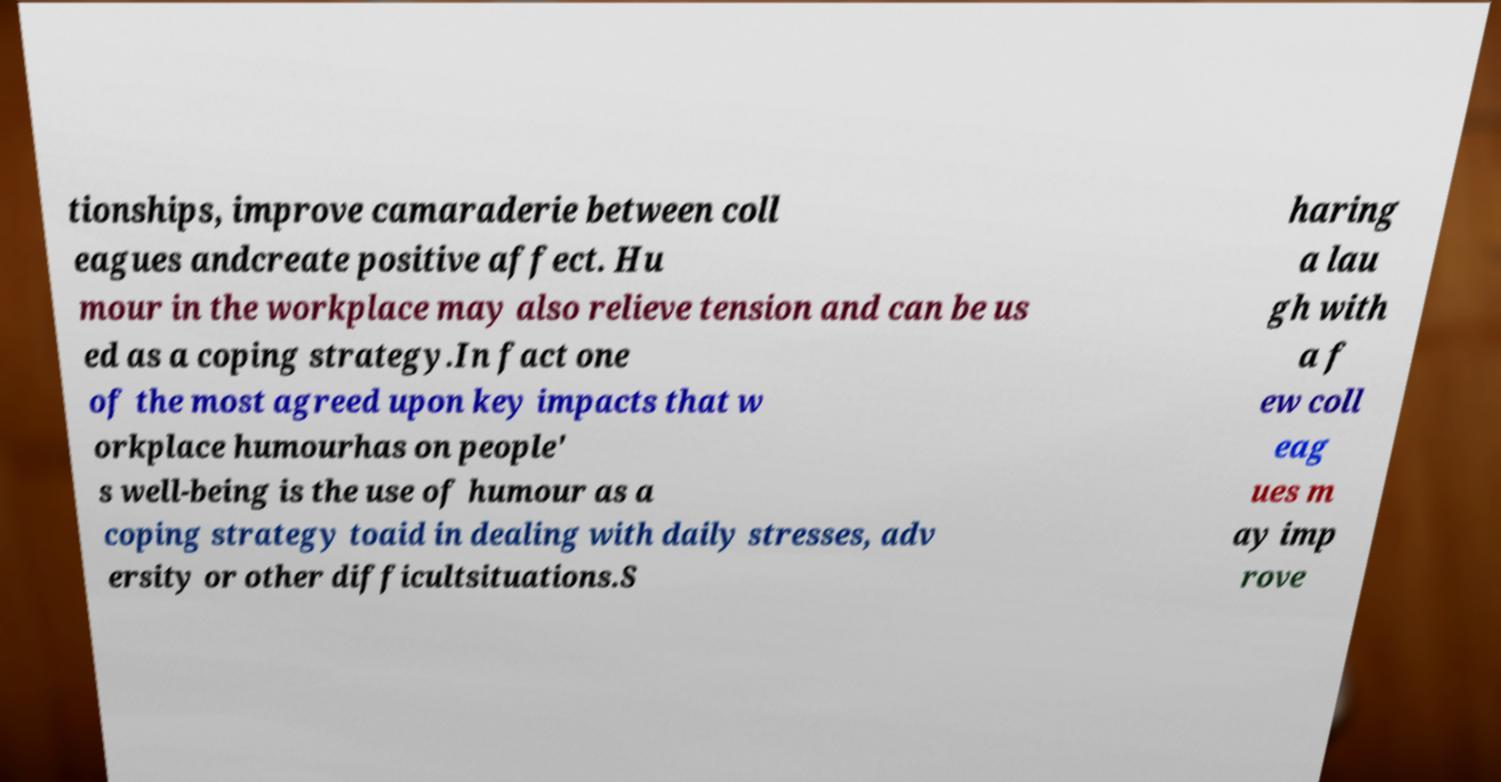There's text embedded in this image that I need extracted. Can you transcribe it verbatim? tionships, improve camaraderie between coll eagues andcreate positive affect. Hu mour in the workplace may also relieve tension and can be us ed as a coping strategy.In fact one of the most agreed upon key impacts that w orkplace humourhas on people' s well-being is the use of humour as a coping strategy toaid in dealing with daily stresses, adv ersity or other difficultsituations.S haring a lau gh with a f ew coll eag ues m ay imp rove 